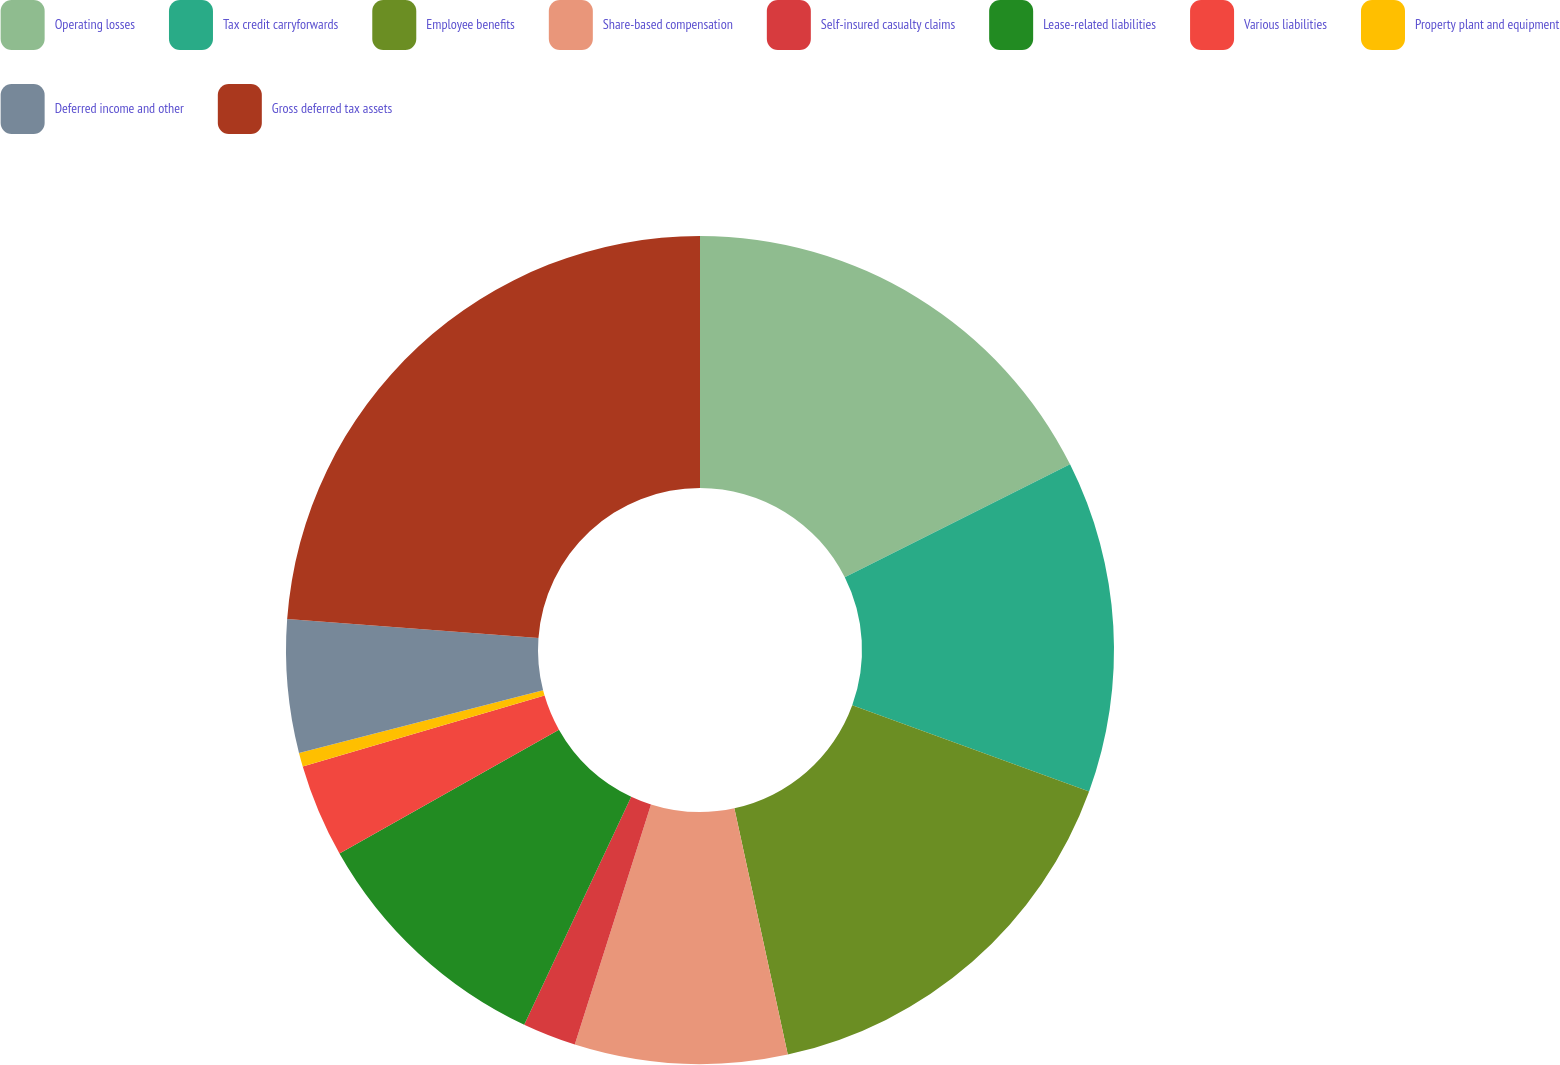Convert chart to OTSL. <chart><loc_0><loc_0><loc_500><loc_500><pie_chart><fcel>Operating losses<fcel>Tax credit carryforwards<fcel>Employee benefits<fcel>Share-based compensation<fcel>Self-insured casualty claims<fcel>Lease-related liabilities<fcel>Various liabilities<fcel>Property plant and equipment<fcel>Deferred income and other<fcel>Gross deferred tax assets<nl><fcel>17.6%<fcel>12.95%<fcel>16.05%<fcel>8.29%<fcel>2.09%<fcel>9.84%<fcel>3.64%<fcel>0.54%<fcel>5.19%<fcel>23.81%<nl></chart> 